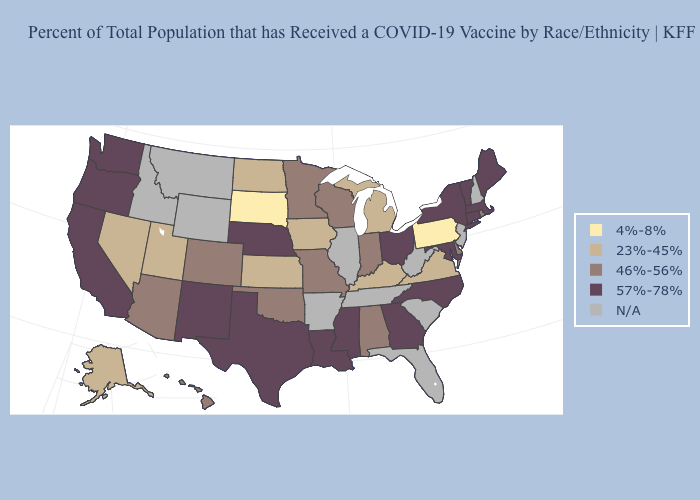Among the states that border Virginia , which have the highest value?
Short answer required. Maryland, North Carolina. Among the states that border Tennessee , does Alabama have the lowest value?
Write a very short answer. No. Among the states that border Illinois , does Iowa have the lowest value?
Keep it brief. Yes. Does Alaska have the lowest value in the West?
Answer briefly. Yes. What is the value of Nebraska?
Concise answer only. 57%-78%. Among the states that border Tennessee , which have the highest value?
Quick response, please. Georgia, Mississippi, North Carolina. Name the states that have a value in the range 46%-56%?
Quick response, please. Alabama, Arizona, Colorado, Delaware, Hawaii, Indiana, Minnesota, Missouri, Oklahoma, Rhode Island, Wisconsin. Among the states that border Idaho , does Utah have the highest value?
Quick response, please. No. What is the value of Michigan?
Answer briefly. 23%-45%. Which states hav the highest value in the MidWest?
Give a very brief answer. Nebraska, Ohio. Among the states that border Massachusetts , does Rhode Island have the highest value?
Be succinct. No. Does Arizona have the highest value in the West?
Answer briefly. No. Does Virginia have the highest value in the USA?
Quick response, please. No. How many symbols are there in the legend?
Short answer required. 5. 